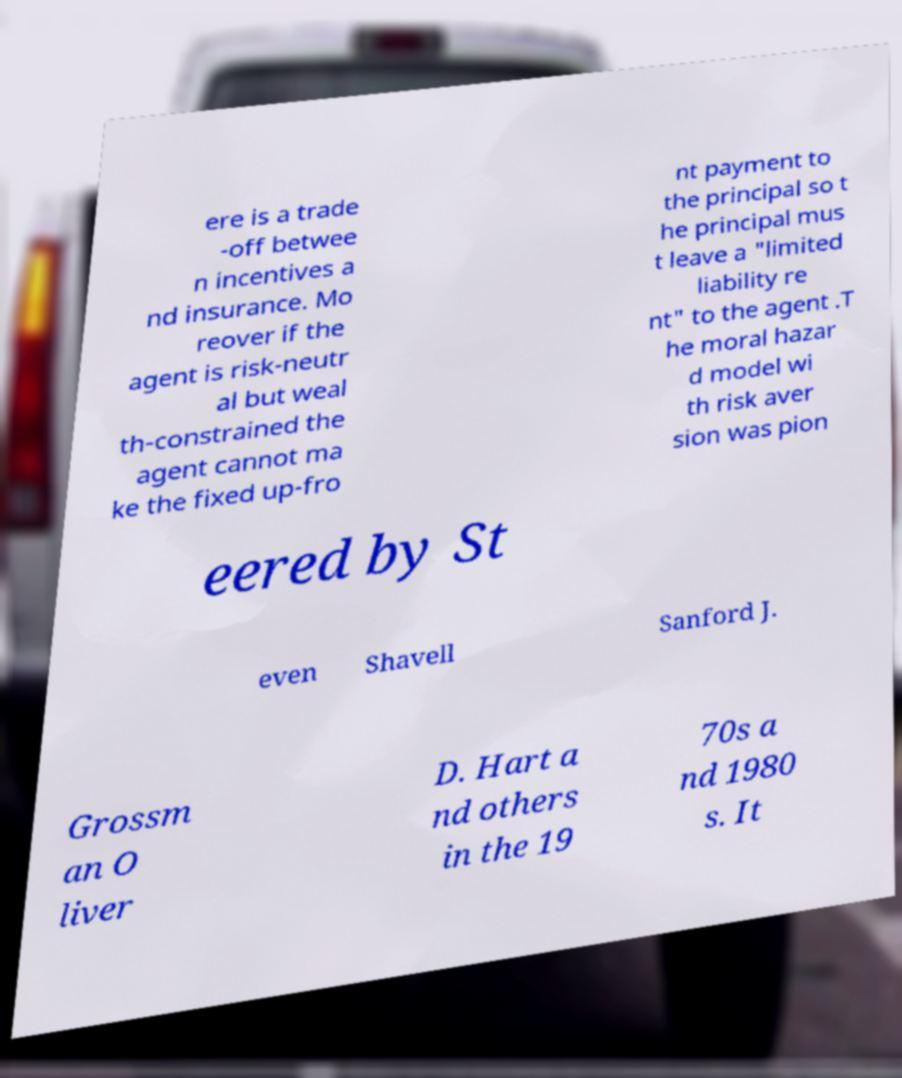Can you read and provide the text displayed in the image?This photo seems to have some interesting text. Can you extract and type it out for me? ere is a trade -off betwee n incentives a nd insurance. Mo reover if the agent is risk-neutr al but weal th-constrained the agent cannot ma ke the fixed up-fro nt payment to the principal so t he principal mus t leave a "limited liability re nt" to the agent .T he moral hazar d model wi th risk aver sion was pion eered by St even Shavell Sanford J. Grossm an O liver D. Hart a nd others in the 19 70s a nd 1980 s. It 